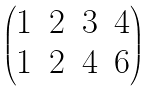Convert formula to latex. <formula><loc_0><loc_0><loc_500><loc_500>\begin{pmatrix} 1 & 2 & 3 & 4 \\ 1 & 2 & 4 & 6 \end{pmatrix}</formula> 